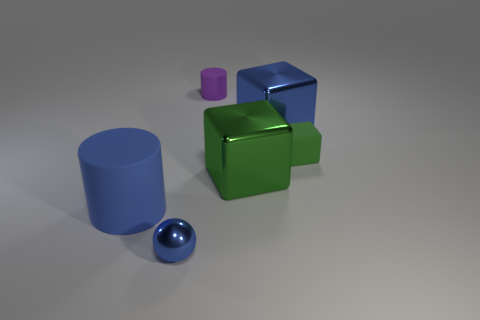There is another rubber object that is the same size as the purple matte object; what is its color?
Your answer should be very brief. Green. How many objects are left of the blue cube and behind the rubber cube?
Keep it short and to the point. 1. There is a large thing that is the same color as the tiny block; what is its shape?
Keep it short and to the point. Cube. The small thing that is in front of the purple cylinder and behind the big cylinder is made of what material?
Provide a succinct answer. Rubber. Are there fewer large matte objects that are behind the metal sphere than large blue rubber things that are in front of the big blue rubber cylinder?
Offer a very short reply. No. What size is the purple object that is the same material as the tiny block?
Your answer should be very brief. Small. Are there any other things of the same color as the tiny matte cylinder?
Provide a short and direct response. No. Does the blue cylinder have the same material as the green block in front of the small green rubber block?
Your response must be concise. No. There is another object that is the same shape as the large rubber thing; what is it made of?
Your answer should be compact. Rubber. Are there any other things that have the same material as the large green thing?
Make the answer very short. Yes. 